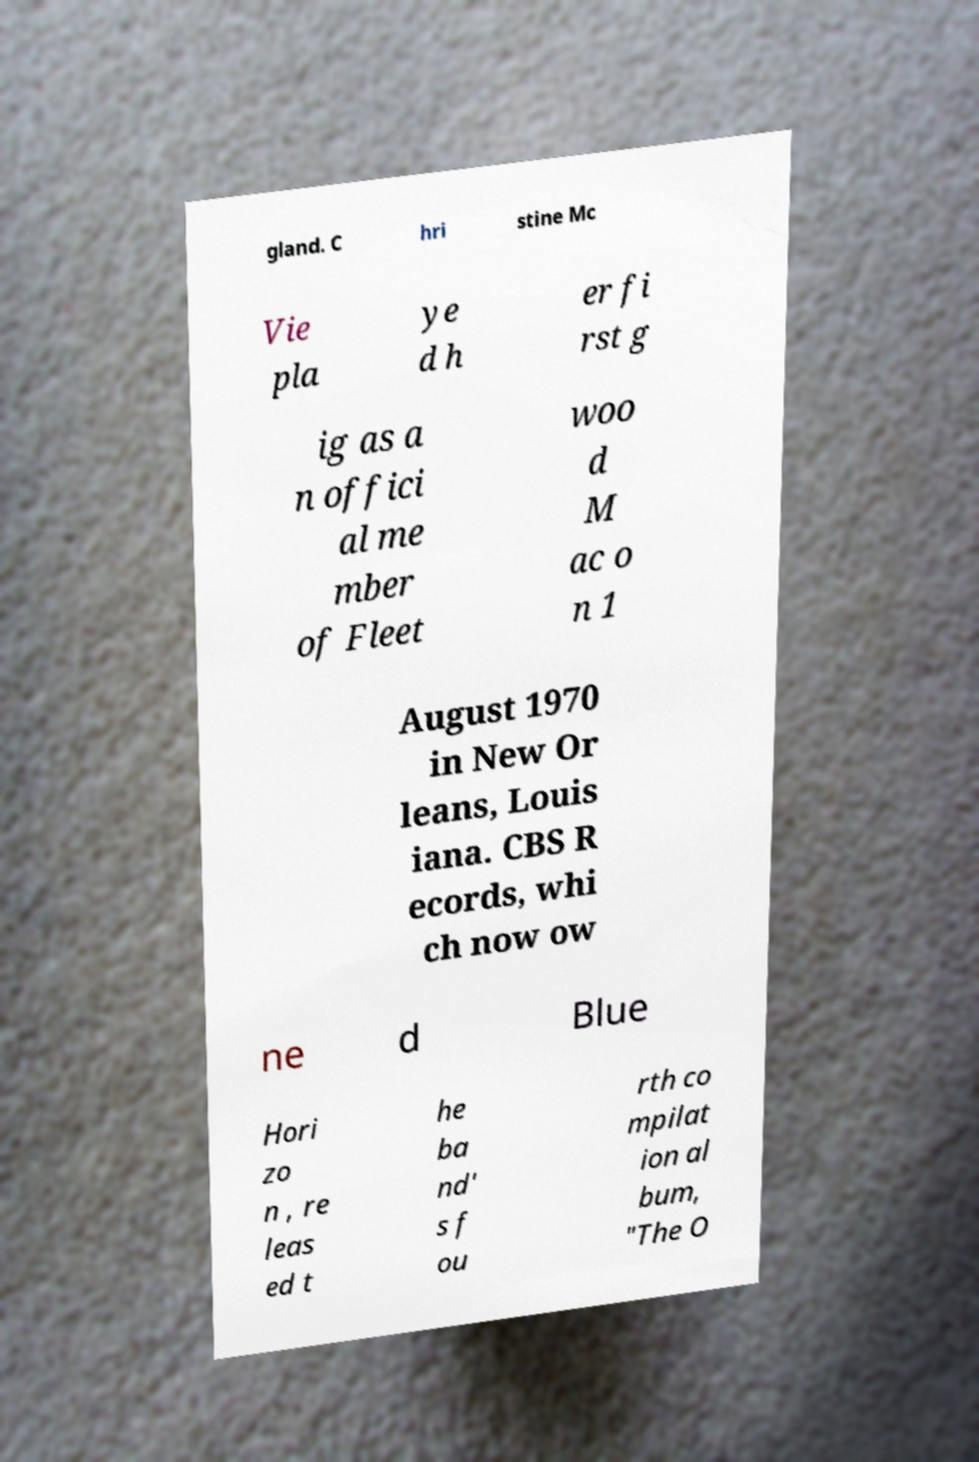Could you assist in decoding the text presented in this image and type it out clearly? gland. C hri stine Mc Vie pla ye d h er fi rst g ig as a n offici al me mber of Fleet woo d M ac o n 1 August 1970 in New Or leans, Louis iana. CBS R ecords, whi ch now ow ne d Blue Hori zo n , re leas ed t he ba nd' s f ou rth co mpilat ion al bum, "The O 